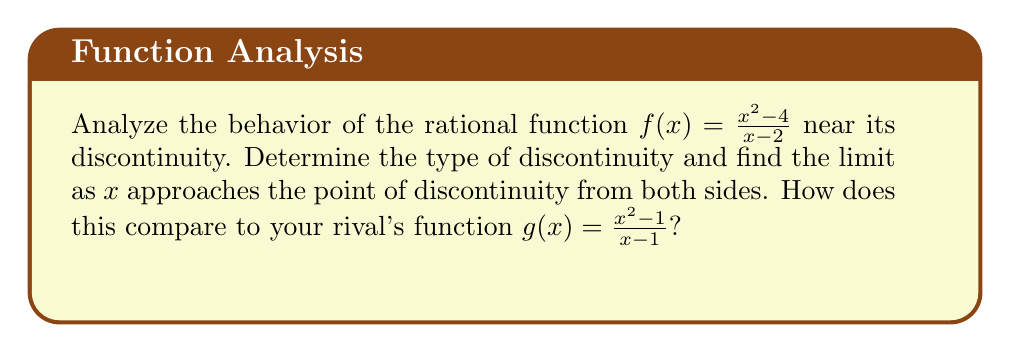Could you help me with this problem? Let's analyze $f(x) = \frac{x^2 - 4}{x - 2}$ step by step:

1) First, let's find the point of discontinuity:
   The denominator is zero when $x - 2 = 0$, so $x = 2$.

2) To determine the type of discontinuity, let's factor the numerator:
   $f(x) = \frac{(x+2)(x-2)}{x-2}$

3) We can cancel $(x-2)$ from numerator and denominator:
   $f(x) = x + 2$ for $x \neq 2$

4) Now, let's find the limits as $x$ approaches 2 from both sides:

   $\lim_{x \to 2^-} f(x) = \lim_{x \to 2^-} (x + 2) = 4$
   $\lim_{x \to 2^+} f(x) = \lim_{x \to 2^+} (x + 2) = 4$

5) Both one-sided limits exist and are equal. Moreover, $f(2)$ is undefined.

6) This indicates a removable discontinuity (hole) at $x = 2$.

For the rival's function $g(x) = \frac{x^2 - 1}{x - 1}$:

7) Following the same process:
   $g(x) = \frac{(x+1)(x-1)}{x-1} = x + 1$ for $x \neq 1$

8) It has a removable discontinuity at $x = 1$.

9) $\lim_{x \to 1} g(x) = 2$

Both functions exhibit similar behavior near their discontinuities, but $f(x)$ has a higher y-value at its discontinuity point.
Answer: Removable discontinuity at $x = 2$; $\lim_{x \to 2} f(x) = 4$ 